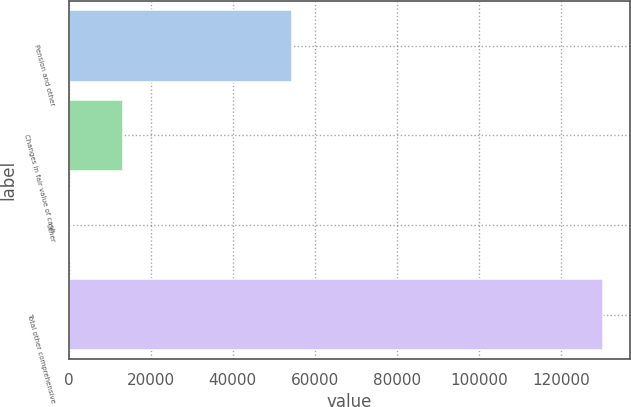<chart> <loc_0><loc_0><loc_500><loc_500><bar_chart><fcel>Pension and other<fcel>Changes in fair value of cash<fcel>Other<fcel>Total other comprehensive<nl><fcel>54519<fcel>13280.4<fcel>270<fcel>130374<nl></chart> 